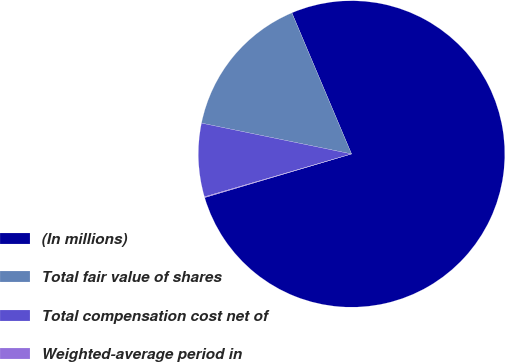Convert chart. <chart><loc_0><loc_0><loc_500><loc_500><pie_chart><fcel>(In millions)<fcel>Total fair value of shares<fcel>Total compensation cost net of<fcel>Weighted-average period in<nl><fcel>76.77%<fcel>15.41%<fcel>7.74%<fcel>0.08%<nl></chart> 